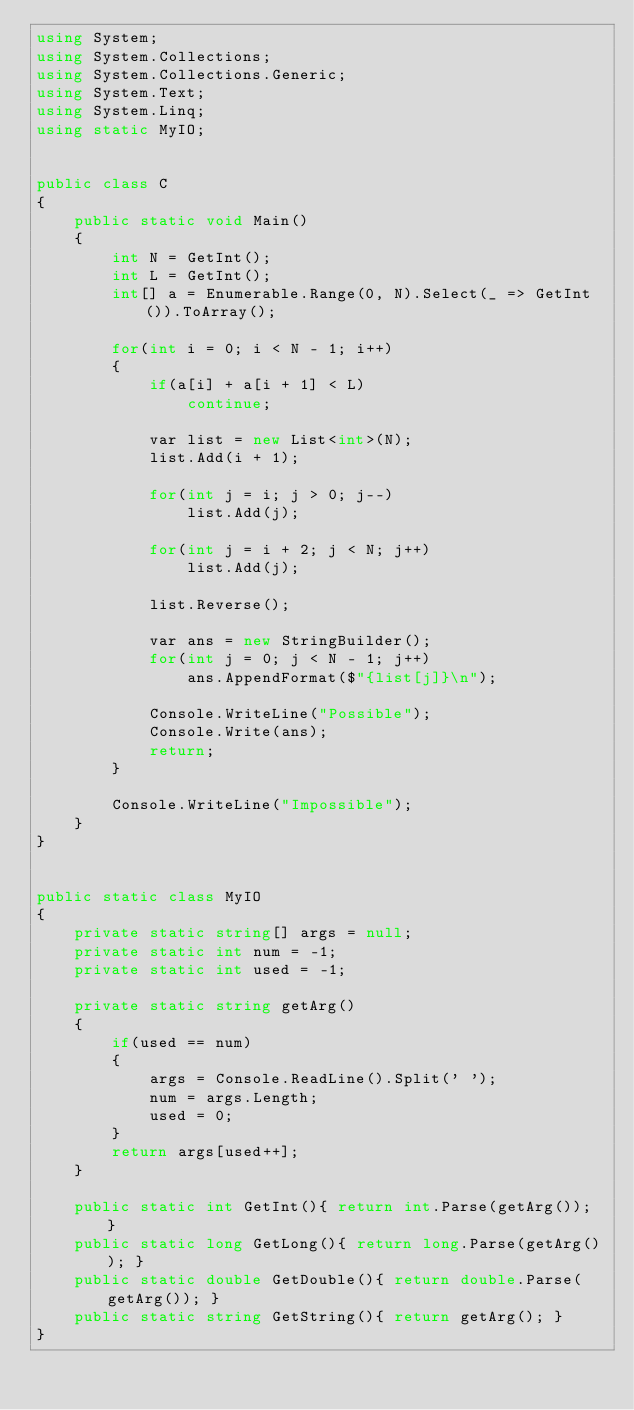<code> <loc_0><loc_0><loc_500><loc_500><_C#_>using System;
using System.Collections;
using System.Collections.Generic;
using System.Text;
using System.Linq;
using static MyIO;


public class C
{
	public static void Main()
	{
		int N = GetInt();
		int L = GetInt();
		int[] a = Enumerable.Range(0, N).Select(_ => GetInt()).ToArray();

		for(int i = 0; i < N - 1; i++)
		{
			if(a[i] + a[i + 1] < L)
				continue;

			var list = new List<int>(N);
			list.Add(i + 1);

			for(int j = i; j > 0; j--)
				list.Add(j);

			for(int j = i + 2; j < N; j++)
				list.Add(j);

			list.Reverse();

			var ans = new StringBuilder();
			for(int j = 0; j < N - 1; j++)
				ans.AppendFormat($"{list[j]}\n");

			Console.WriteLine("Possible");
			Console.Write(ans);
			return;
		}

		Console.WriteLine("Impossible");
	}
}


public static class MyIO
{
	private static string[] args = null;
	private static int num = -1;
	private static int used = -1;

	private static string getArg()
	{
		if(used == num)
		{
			args = Console.ReadLine().Split(' ');
			num = args.Length;
			used = 0;
		}
		return args[used++];
	}

	public static int GetInt(){ return int.Parse(getArg()); }
	public static long GetLong(){ return long.Parse(getArg()); }
	public static double GetDouble(){ return double.Parse(getArg()); }
	public static string GetString(){ return getArg(); }
}
</code> 